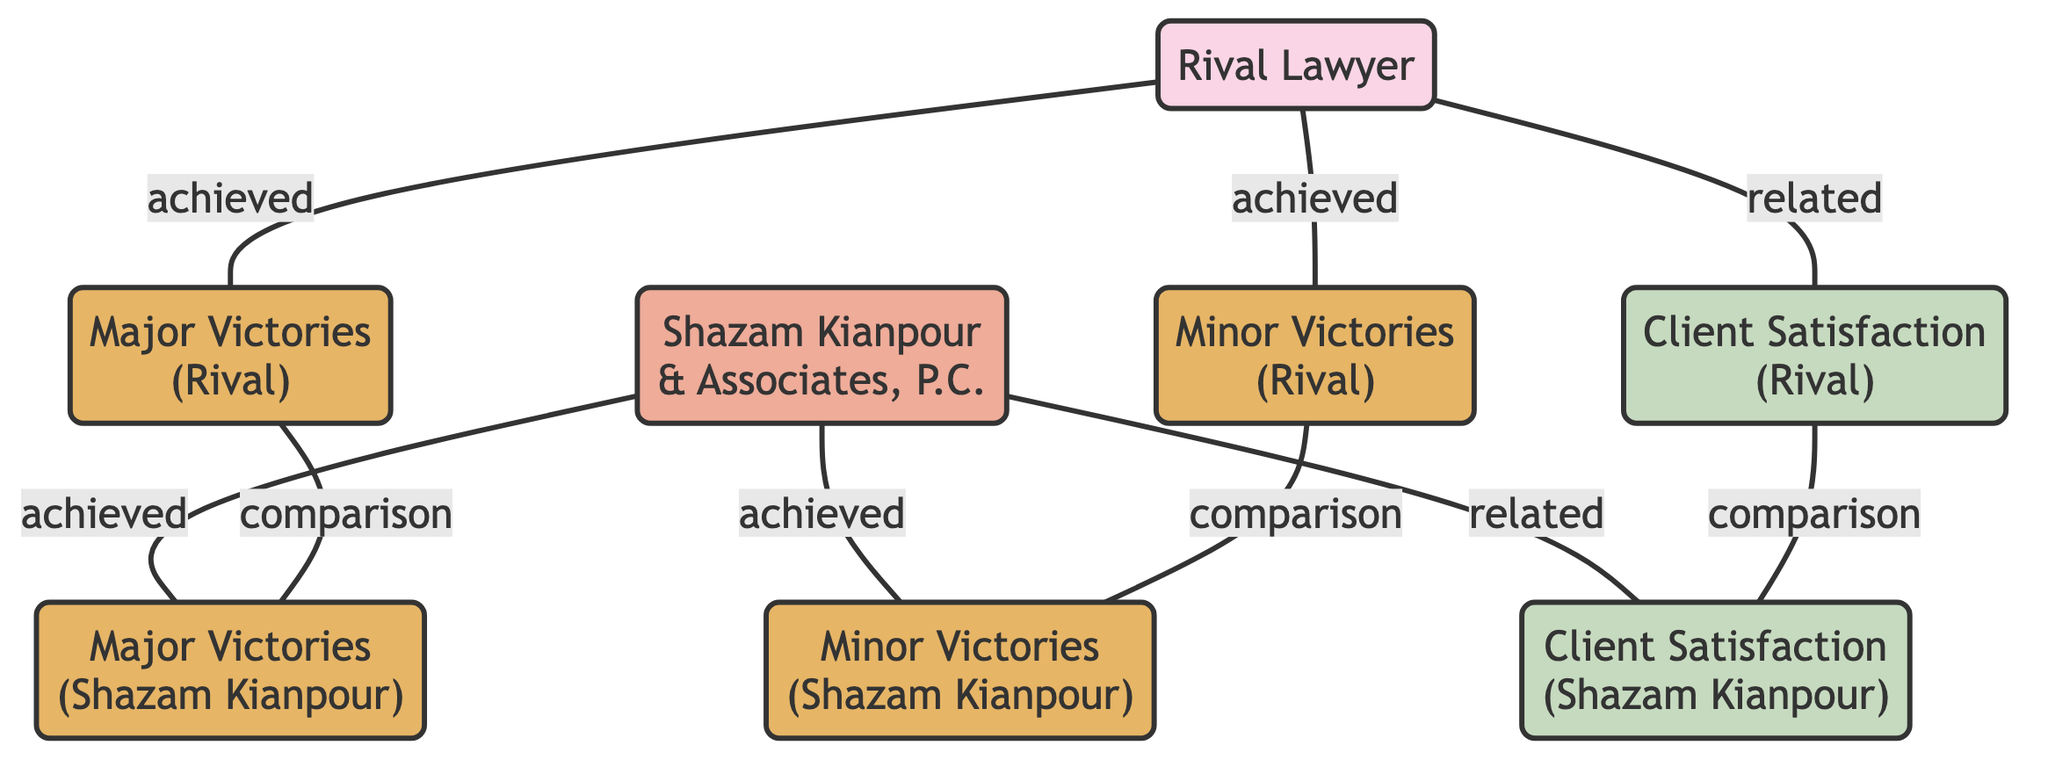What is the total number of nodes in the diagram? The diagram includes 8 unique nodes: Rival Lawyer, Shazam Kianpour & Associates, P.C., Major Victories (Rival), Minor Victories (Rival), Major Victories (Shazam Kianpour), Minor Victories (Shazam Kianpour), Client Satisfaction (Rival), and Client Satisfaction (Shazam Kianpour). Therefore, the total count is 8.
Answer: 8 Which firm has achieved more major victories? The diagram shows a comparison edge between Major Victories (Rival) and Major Victories (Shazam Kianpour) but does not specify the counts. The structured relationship indicates that both firms have major victories to compare. However, without specific values, the answer is indeterminate.
Answer: Indeterminate What type of relationship exists between the rival lawyer and client satisfaction? The diagram indicates a 'related' connection between the Rival Lawyer and Client Satisfaction (Rival). This signifies a link that reflects the potential impact of the lawyer's performance on client satisfaction.
Answer: related Who achieved more minor victories according to the diagram? Similar to the major victories, there is a comparison edge between Minor Victories (Rival) and Minor Victories (Shazam Kianpour). However, specific counts are not provided, hence the conclusion remains unclear.
Answer: Indeterminate How many comparison edges are there in total? The diagram lists three comparison edges: Major Victories (Rival) to Major Victories (Shazam Kianpour), Minor Victories (Rival) to Minor Victories (Shazam Kianpour), and Client Satisfaction (Rival) to Client Satisfaction (Shazam Kianpour). Thus, there are three comparison edges in total.
Answer: 3 Which entity is connected to the minor victories of the rival? The diagram shows a direct "achieved" edge from the rival lawyer to Minor Victories (Rival), indicating that the rival lawyer is the party associated with these minor victories.
Answer: Rival Lawyer 